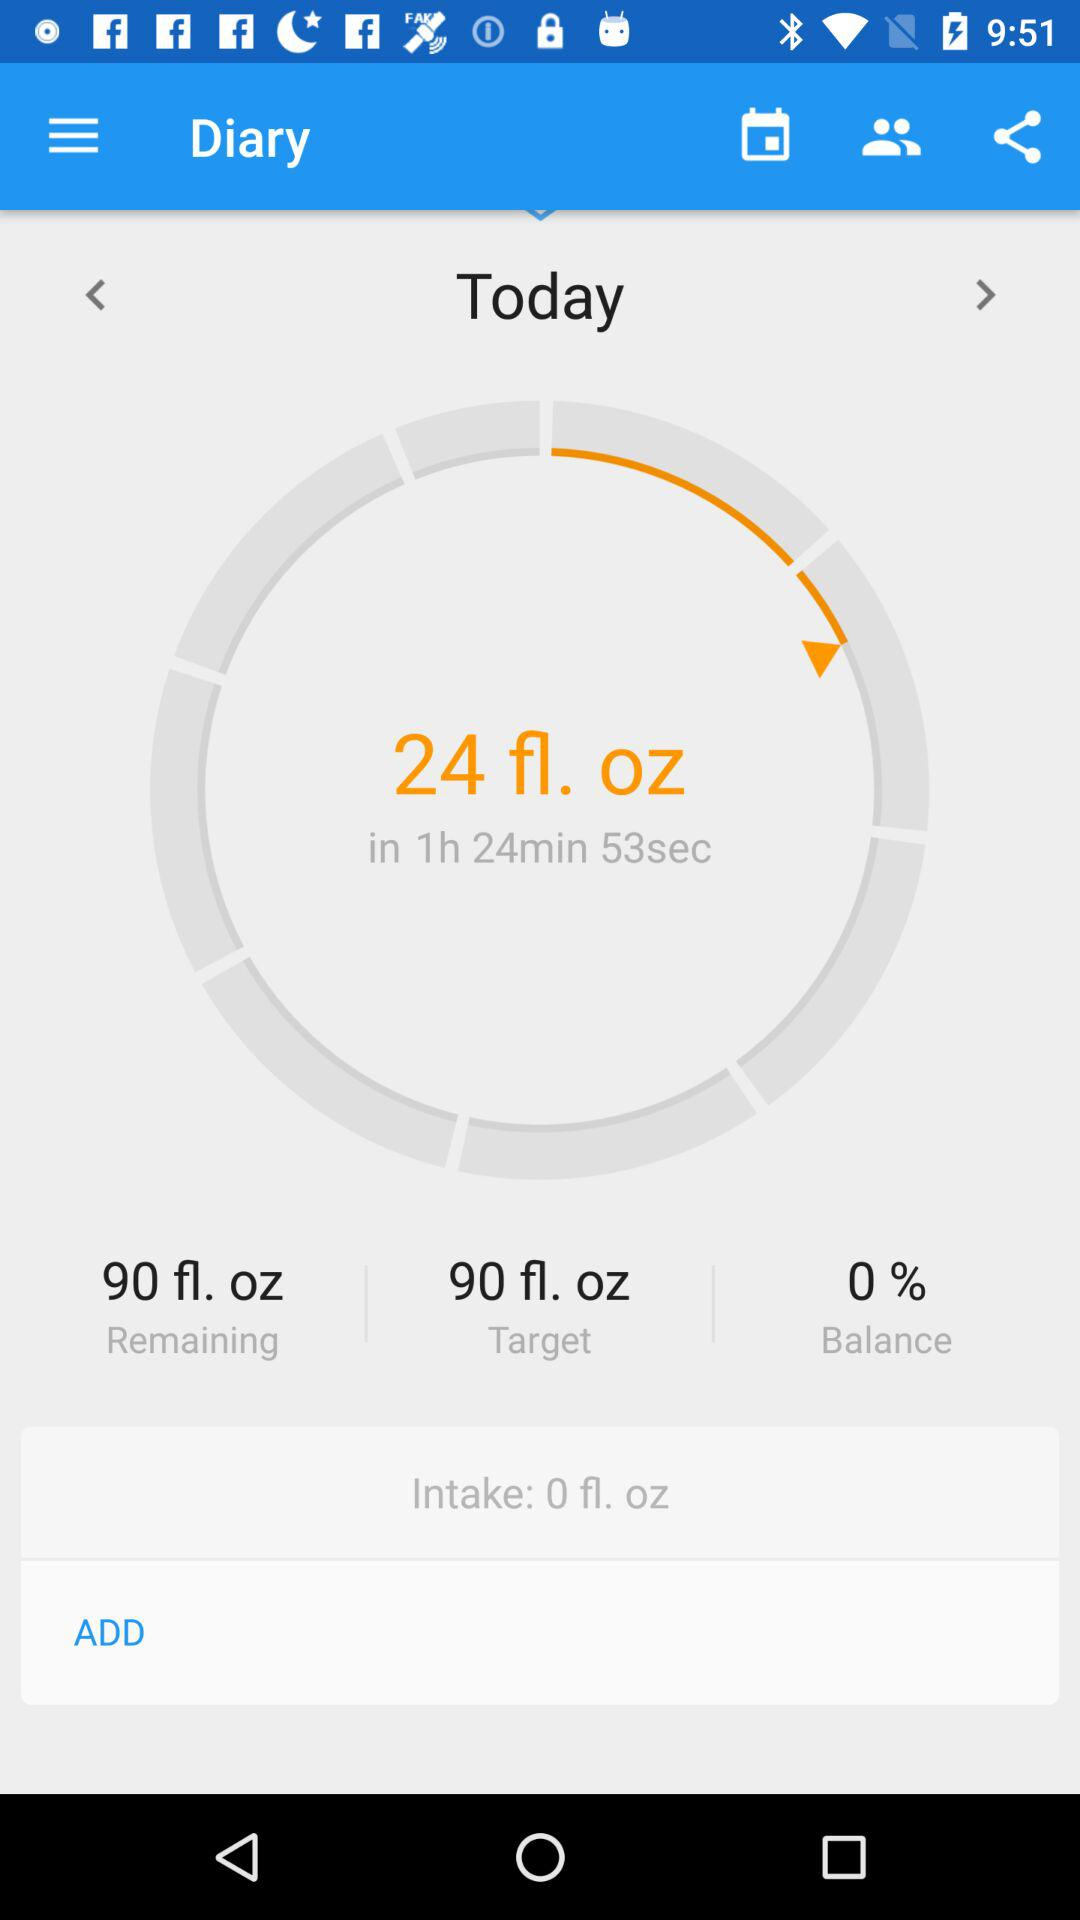How much water do I need to drink?
Answer the question using a single word or phrase. 90 fl. oz 